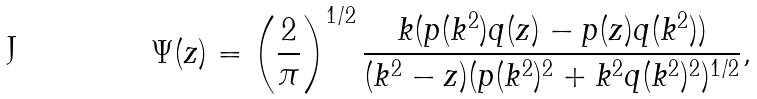Convert formula to latex. <formula><loc_0><loc_0><loc_500><loc_500>\Psi ( z ) = \left ( \frac { 2 } { \pi } \right ) ^ { 1 / 2 } \frac { k ( p ( k ^ { 2 } ) q ( z ) - p ( z ) q ( k ^ { 2 } ) ) } { ( k ^ { 2 } - z ) ( p ( k ^ { 2 } ) ^ { 2 } + k ^ { 2 } q ( k ^ { 2 } ) ^ { 2 } ) ^ { 1 / 2 } } ,</formula> 